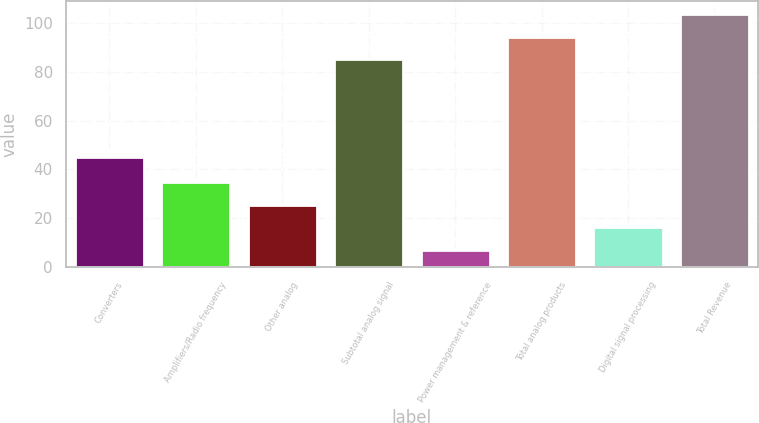<chart> <loc_0><loc_0><loc_500><loc_500><bar_chart><fcel>Converters<fcel>Amplifiers/Radio frequency<fcel>Other analog<fcel>Subtotal analog signal<fcel>Power management & reference<fcel>Total analog products<fcel>Digital signal processing<fcel>Total Revenue<nl><fcel>45<fcel>34.9<fcel>25.6<fcel>85<fcel>7<fcel>94.3<fcel>16.3<fcel>103.6<nl></chart> 